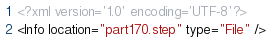<code> <loc_0><loc_0><loc_500><loc_500><_XML_><?xml version='1.0' encoding='UTF-8'?>
<Info location="part170.step" type="File" /></code> 